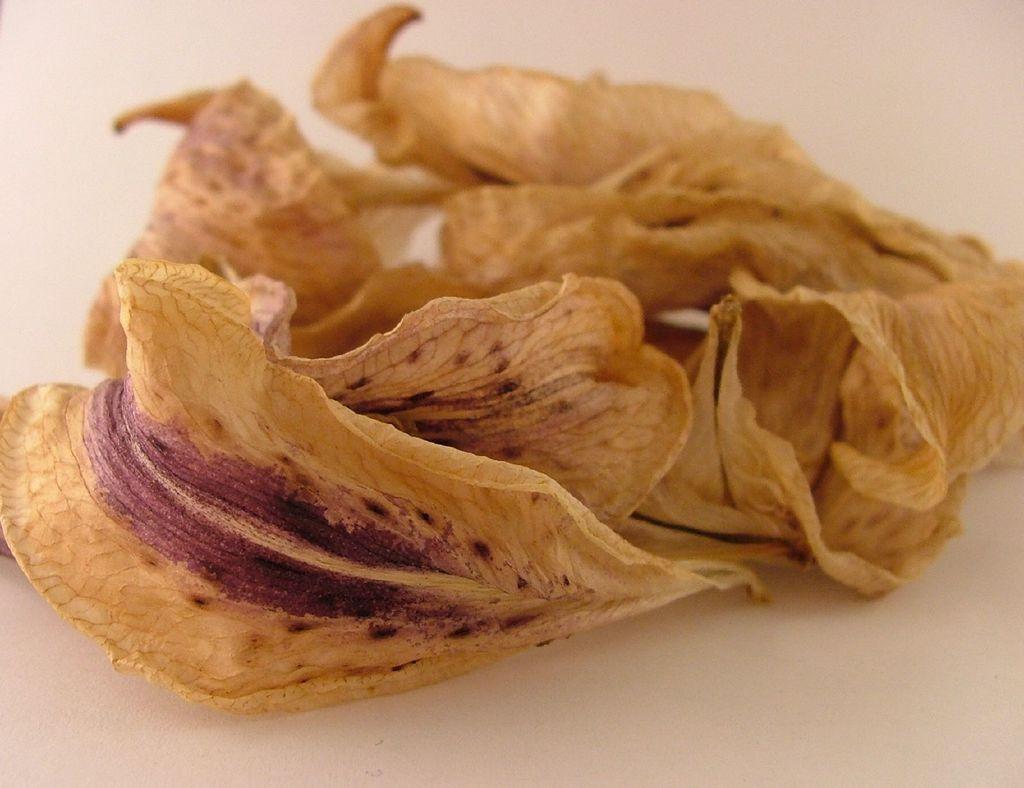Can you describe this image briefly? In this image I can see few dry leaves on a white surface. 